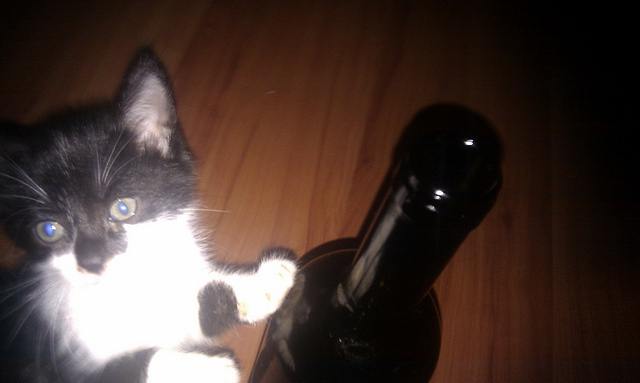Describe the objects in this image and their specific colors. I can see cat in black, white, gray, and darkgray tones and bottle in black, gray, and maroon tones in this image. 